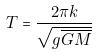<formula> <loc_0><loc_0><loc_500><loc_500>T = \frac { 2 \pi k } { \sqrt { g \overline { G M } } }</formula> 